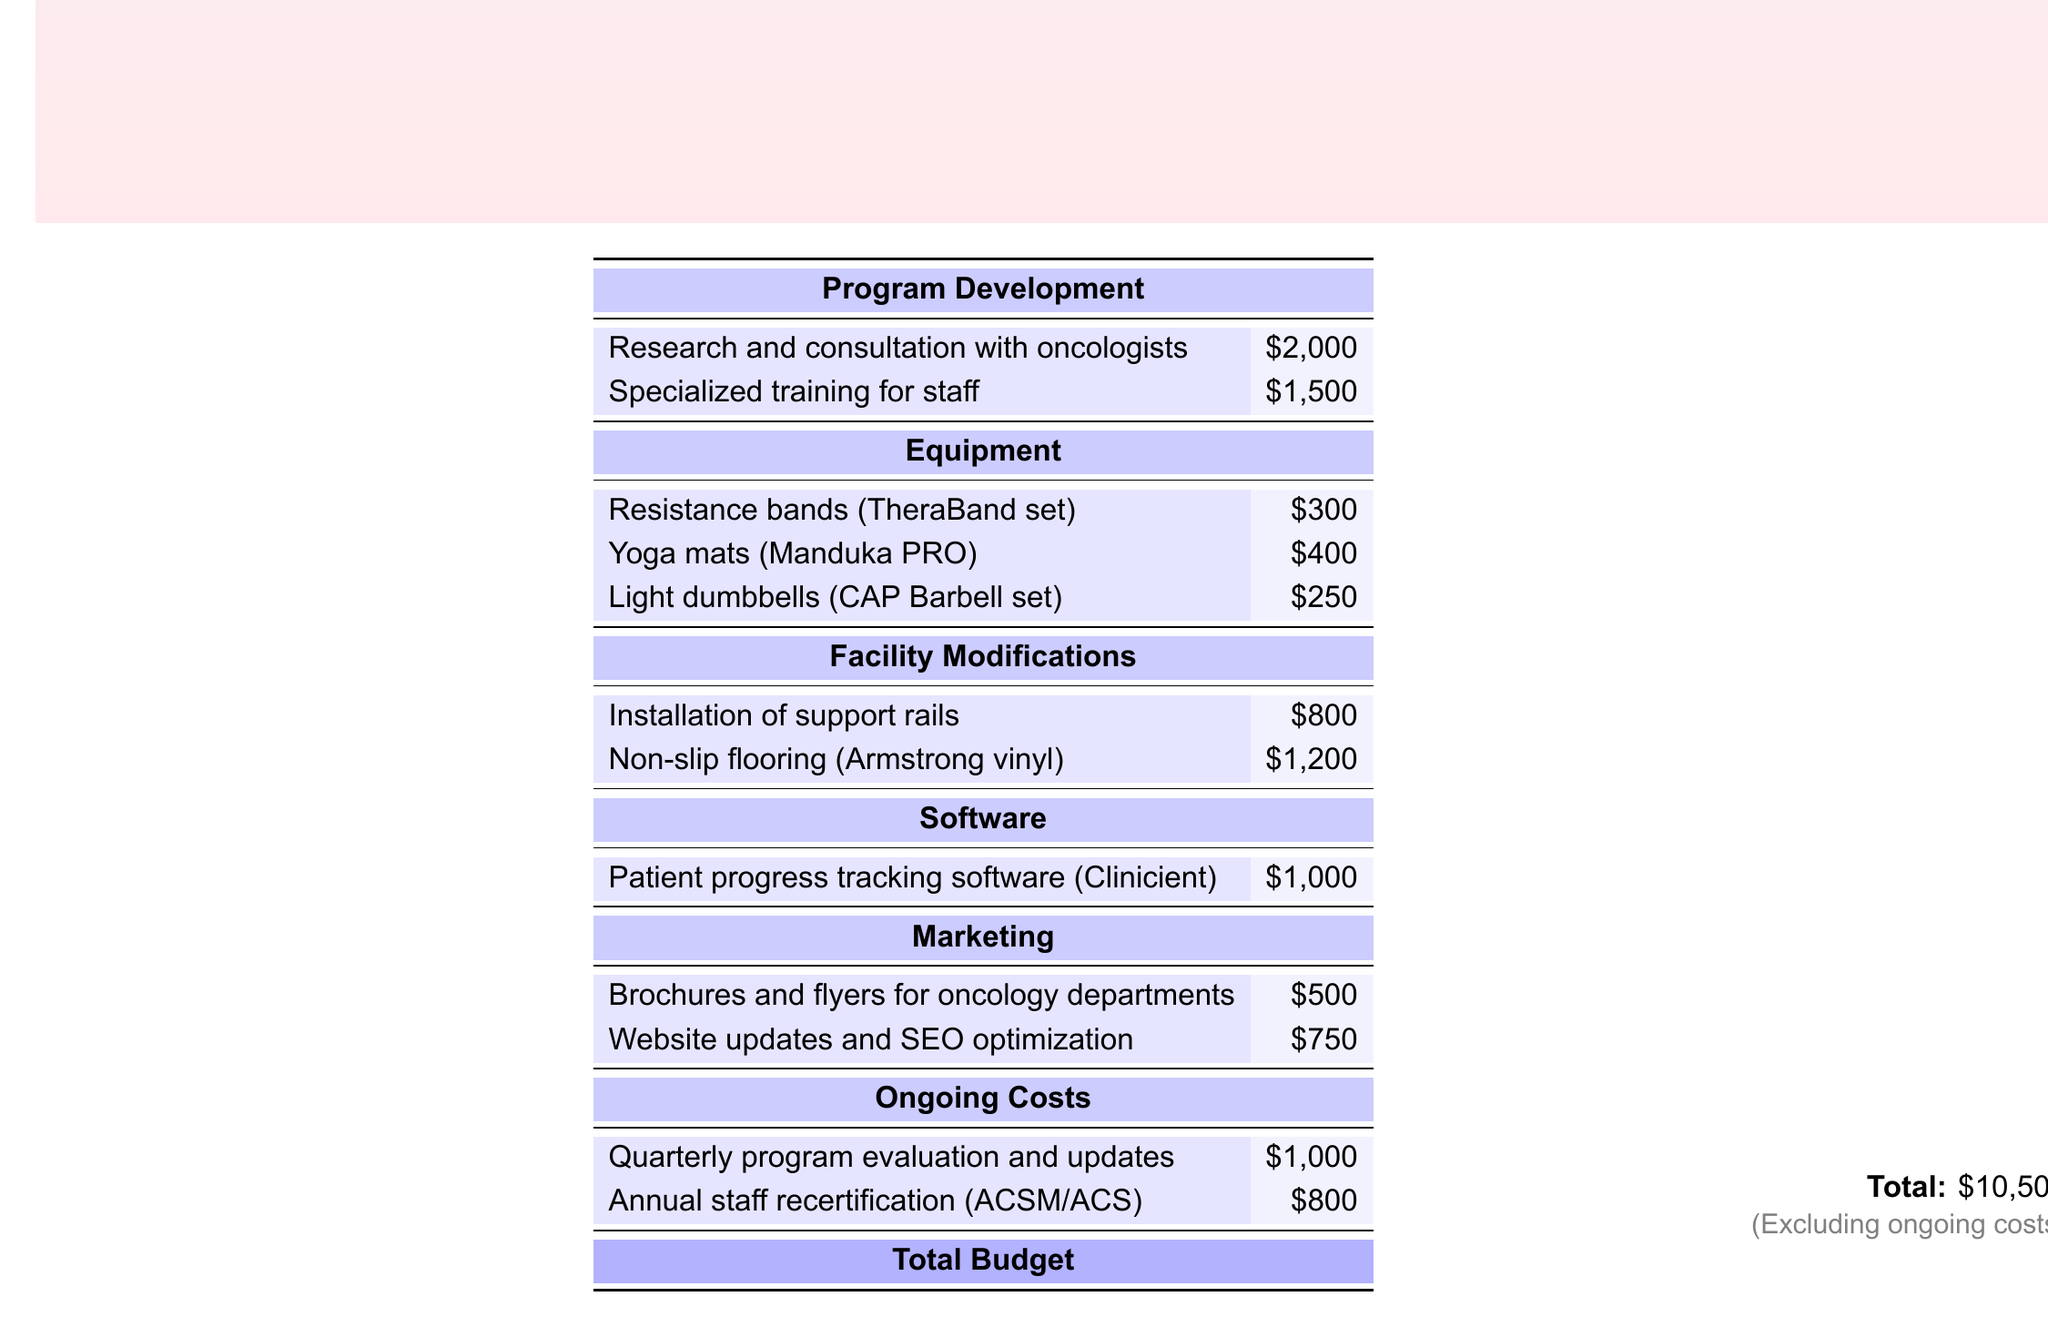What is the total budget? The total budget is displayed at the bottom of the document and excludes ongoing costs.
Answer: $10,500 How much is allocated for equipment? The total allocated for equipment is the sum of all equipment costs listed in the document.
Answer: $950 What is the cost of installing support rails? The document specifies the cost for the installation of support rails in the facility modifications section.
Answer: $800 How much is budgeted for brochures and flyers? The document provides a specific cost for brochures and flyers under the marketing section.
Answer: $500 What is the cost of specialized training for staff? The amount set aside for specialized staff training is mentioned in the program development section.
Answer: $1,500 What item has the highest cost in the facility modifications? The highest cost in the facility modifications is for non-slip flooring, stated in the document.
Answer: $1,200 How much is allocated for annual staff recertification? The document lists the specific budget for annual staff recertification under ongoing costs.
Answer: $800 What software is included in the budget? The specified software for patient progress tracking is mentioned in the software section.
Answer: Clinicient What are the ongoing costs per year? The ongoing costs include evaluation and recertification, which are stated in the document.
Answer: $1,800 